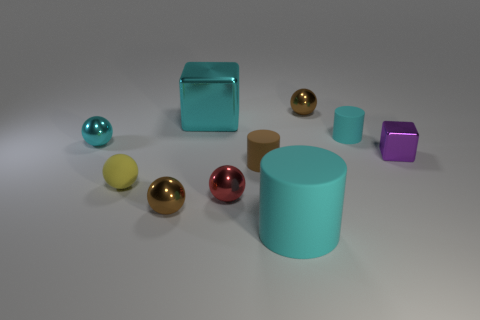Is the color of the metal cube that is behind the tiny cyan matte cylinder the same as the big matte cylinder?
Your response must be concise. Yes. What number of other things are the same color as the tiny shiny cube?
Provide a succinct answer. 0. What number of small things are either cyan balls or objects?
Your answer should be very brief. 8. Are there more small blue rubber balls than tiny yellow objects?
Provide a short and direct response. No. Do the small cyan ball and the tiny purple object have the same material?
Your answer should be compact. Yes. Is there any other thing that has the same material as the purple thing?
Ensure brevity in your answer.  Yes. Is the number of things that are right of the red metal object greater than the number of rubber cylinders?
Your answer should be compact. Yes. Do the big shiny block and the big matte object have the same color?
Offer a very short reply. Yes. How many yellow objects are the same shape as the purple shiny object?
Offer a very short reply. 0. What size is the cyan ball that is made of the same material as the red ball?
Keep it short and to the point. Small. 